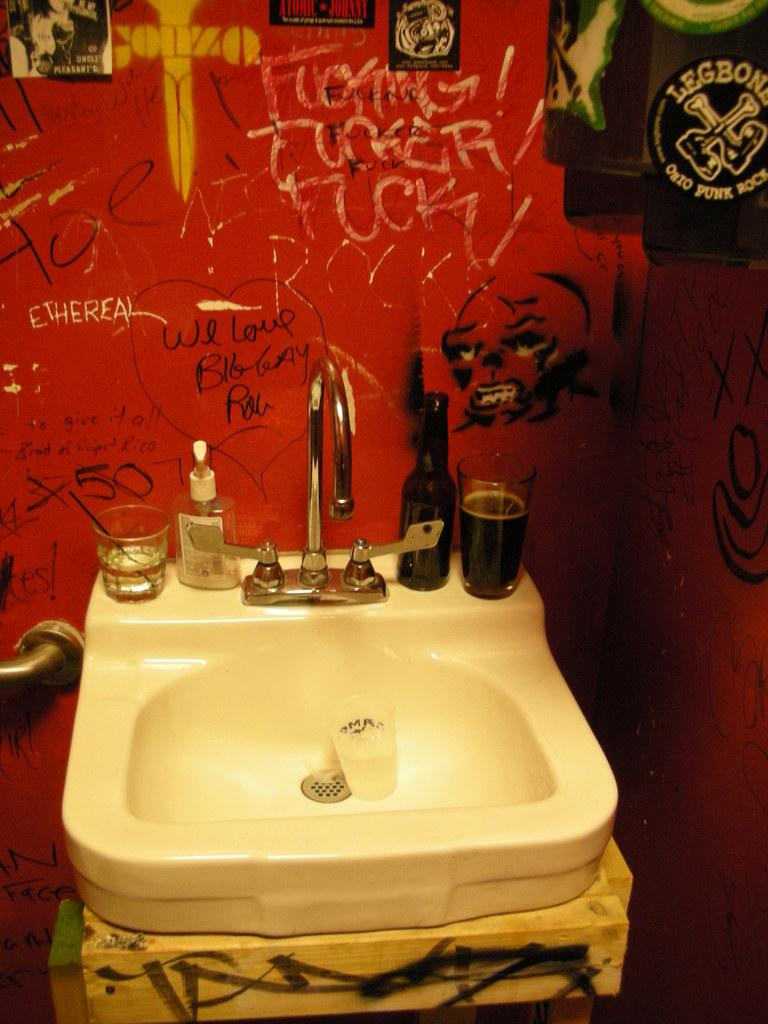What can be found in the image for washing purposes? There is a sink in the image with a tap. What is located near the sink? There is a sanitize bottle near the sink. What type of dishware can be seen in the image? There are glasses in the image. What is the color of the walls in the image? The walls have a red color. What is written or drawn on the walls? There is something scribbled on the walls. How many plants are visible in the image? There are no plants visible in the image. What type of ear is present in the image? There is no ear present in the image. 